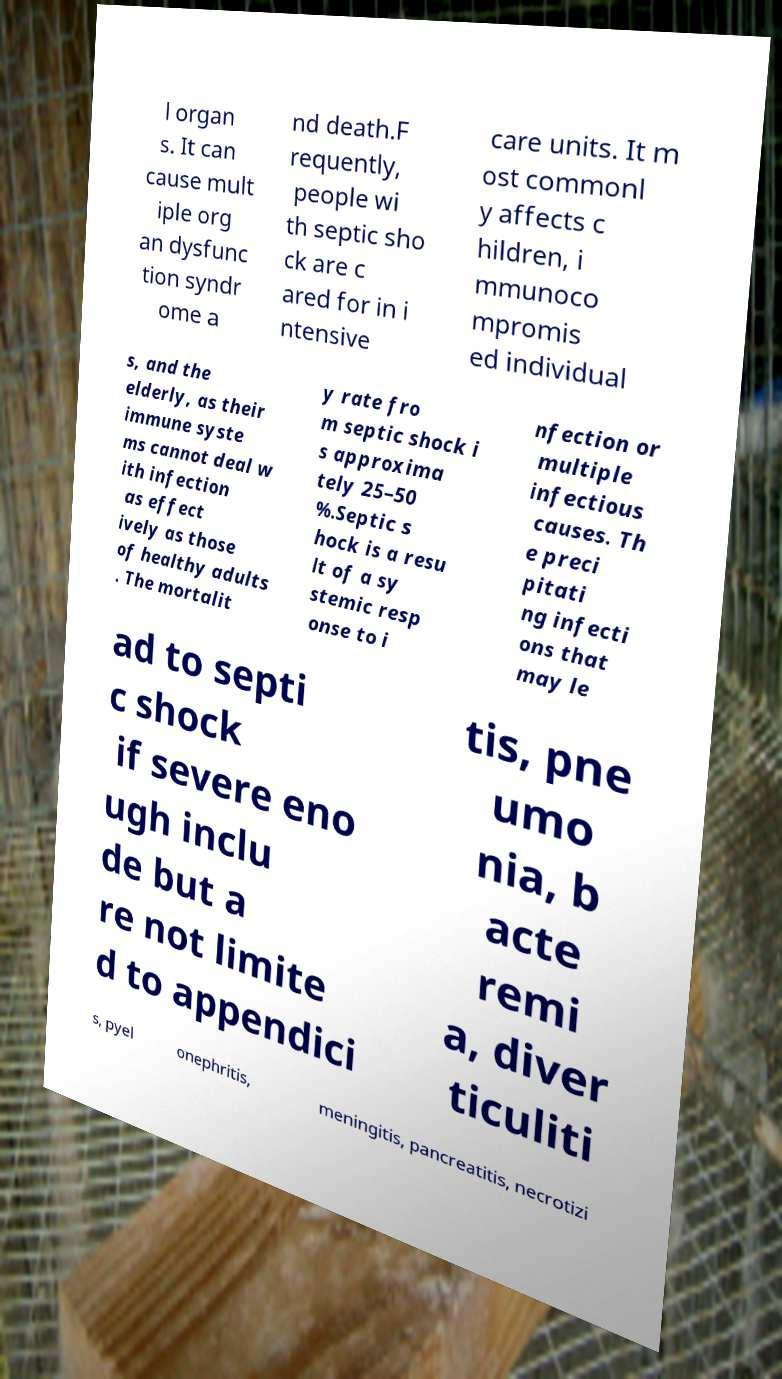Could you extract and type out the text from this image? l organ s. It can cause mult iple org an dysfunc tion syndr ome a nd death.F requently, people wi th septic sho ck are c ared for in i ntensive care units. It m ost commonl y affects c hildren, i mmunoco mpromis ed individual s, and the elderly, as their immune syste ms cannot deal w ith infection as effect ively as those of healthy adults . The mortalit y rate fro m septic shock i s approxima tely 25–50 %.Septic s hock is a resu lt of a sy stemic resp onse to i nfection or multiple infectious causes. Th e preci pitati ng infecti ons that may le ad to septi c shock if severe eno ugh inclu de but a re not limite d to appendici tis, pne umo nia, b acte remi a, diver ticuliti s, pyel onephritis, meningitis, pancreatitis, necrotizi 